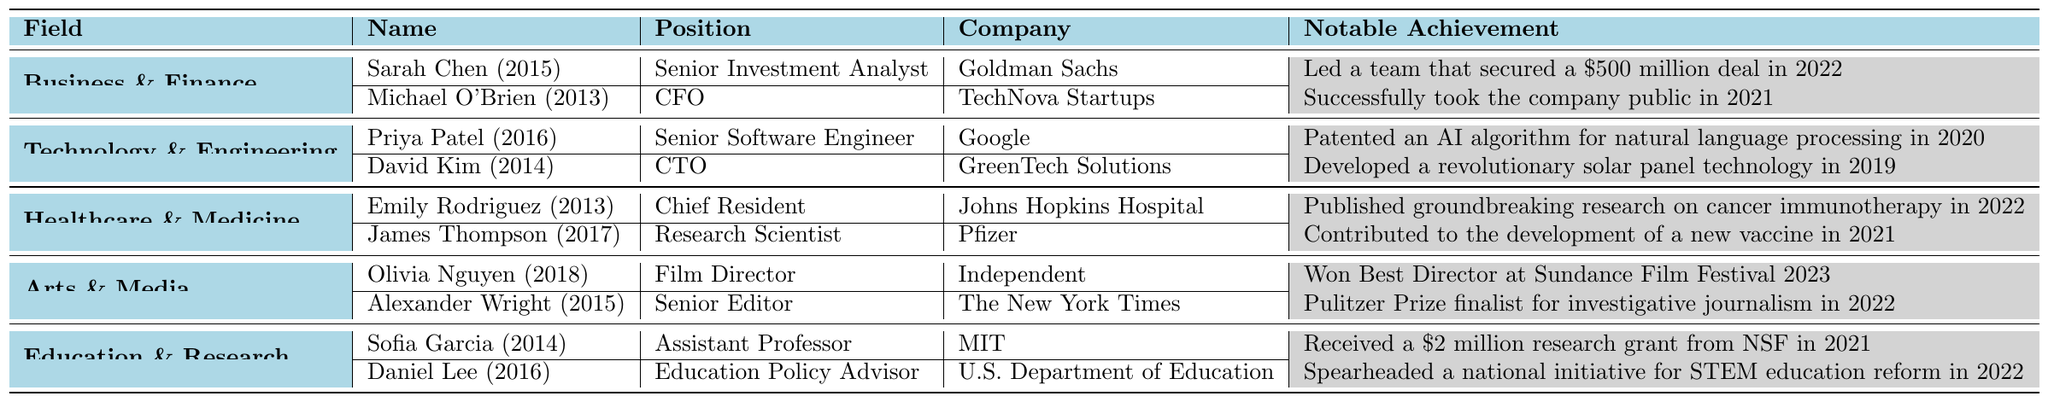What is the notable achievement of Sarah Chen? Sarah Chen's notable achievement as listed in the table is leading a team that secured a $500 million deal in 2022.
Answer: Led a team that secured a $500 million deal in 2022 Which field does Olivia Nguyen work in? According to the table, Olivia Nguyen works in the Arts & Media field as a Film Director.
Answer: Arts & Media Who is the CTO of GreenTech Solutions? The table indicates that David Kim, who graduated in 2014, is the CTO of GreenTech Solutions.
Answer: David Kim How many graduates are mentioned in the Healthcare & Medicine field? The table lists two graduates in Healthcare & Medicine: Emily Rodriguez and James Thompson.
Answer: 2 Did any Claver College alumni work in the Technology & Engineering field patent an AI algorithm? Yes, Priya Patel patented an AI algorithm for natural language processing in 2020.
Answer: Yes Which alumnus has the earliest graduation year in the Business & Finance field? The earliest graduation year in the Business & Finance field is 2013, associated with Michael O'Brien.
Answer: Michael O'Brien Calculate the average graduation year of alumni in the Education & Research field. The graduation years for Sofia Garcia and Daniel Lee are 2014 and 2016, respectively. The average is (2014 + 2016) / 2 = 2015.
Answer: 2015 Who are the alumni that contributed to significant achievements in 2021? Three notable alumni had significant achievements in 2021: Michael O'Brien (took the company public), James Thompson (vaccine contribution), and Sofia Garcia ($2 million research grant).
Answer: Michael O'Brien, James Thompson, Sofia Garcia What is the position of Alexander Wright? According to the table, Alexander Wright holds the position of Senior Editor at The New York Times.
Answer: Senior Editor Does any alumni from Claver College work at Pfizer? Yes, James Thompson works at Pfizer as a Research Scientist.
Answer: Yes 